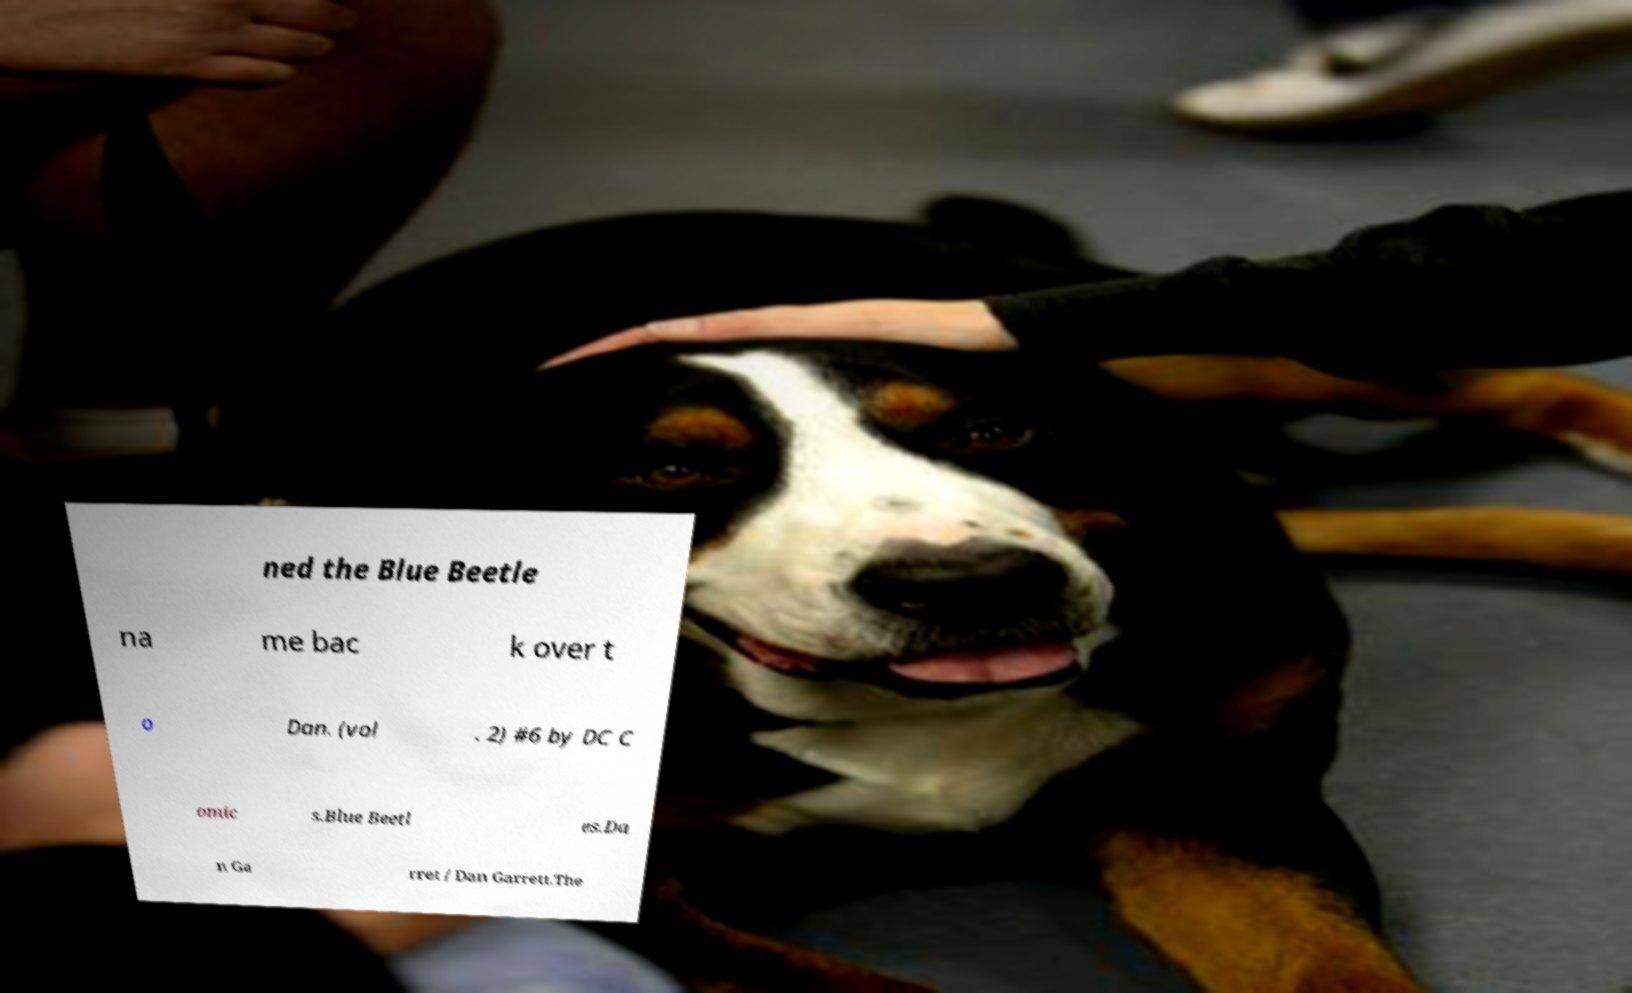There's text embedded in this image that I need extracted. Can you transcribe it verbatim? ned the Blue Beetle na me bac k over t o Dan. (vol . 2) #6 by DC C omic s.Blue Beetl es.Da n Ga rret / Dan Garrett.The 